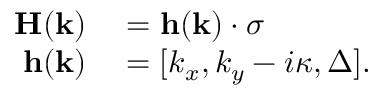Convert formula to latex. <formula><loc_0><loc_0><loc_500><loc_500>\begin{array} { r l } { H ( k ) } & = { h } ( k ) \cdot \sigma } \\ { { h } ( k ) } & = [ k _ { x } , k _ { y } - i \kappa , \Delta ] . } \end{array}</formula> 